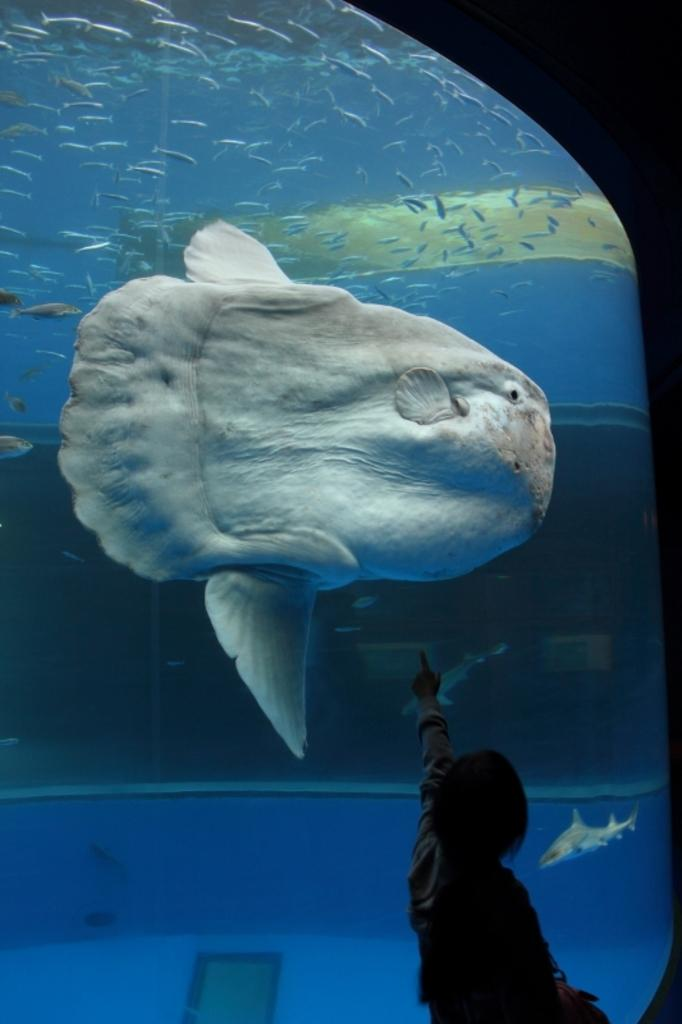What is the main subject of the image? There is a person in the image. What else can be seen in the image besides the person? There are fishes in an aquarium in the image. What type of toothbrush is the person using to feed the fishes in the image? There is no toothbrush present in the image, and the person is not feeding the fishes. 